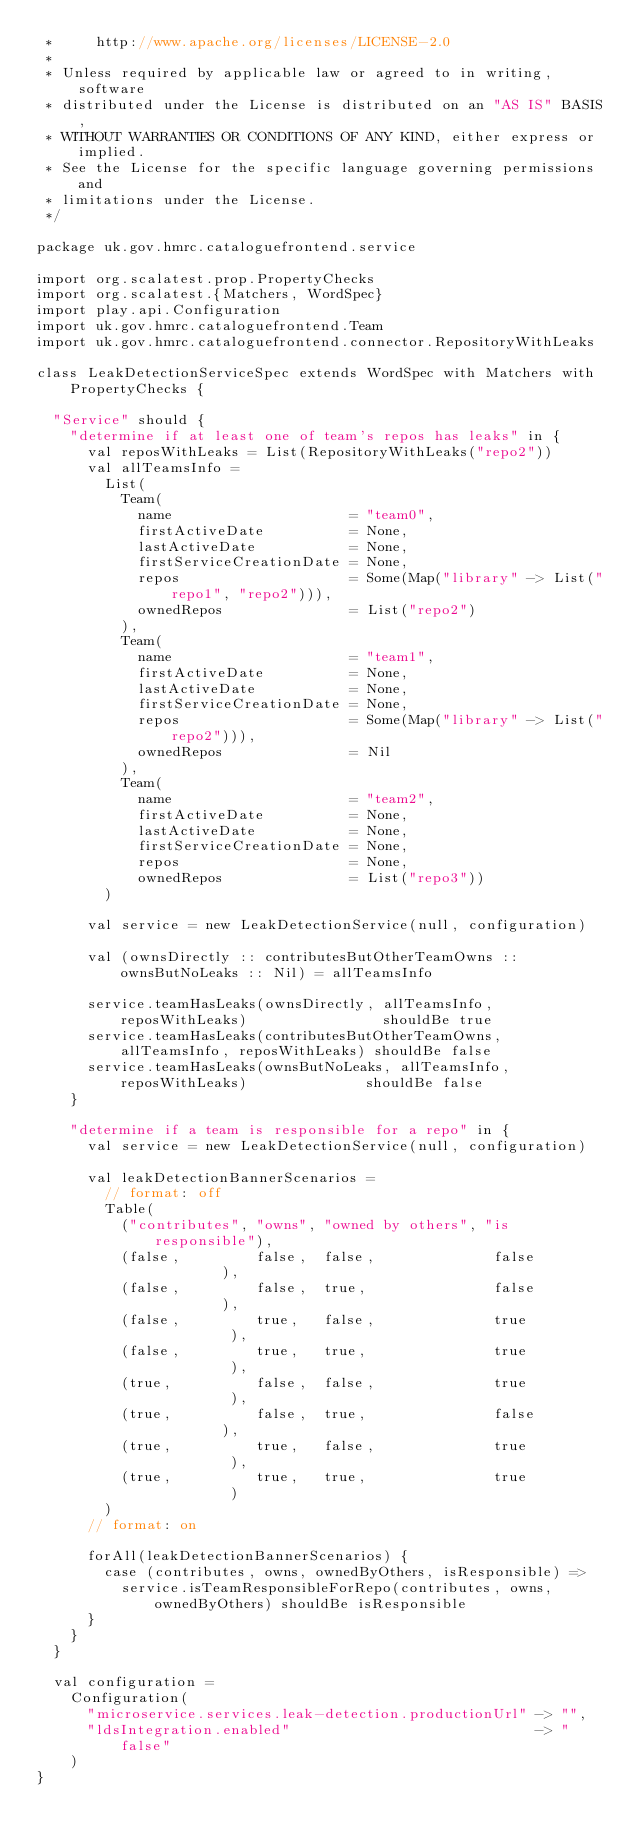Convert code to text. <code><loc_0><loc_0><loc_500><loc_500><_Scala_> *     http://www.apache.org/licenses/LICENSE-2.0
 *
 * Unless required by applicable law or agreed to in writing, software
 * distributed under the License is distributed on an "AS IS" BASIS,
 * WITHOUT WARRANTIES OR CONDITIONS OF ANY KIND, either express or implied.
 * See the License for the specific language governing permissions and
 * limitations under the License.
 */

package uk.gov.hmrc.cataloguefrontend.service

import org.scalatest.prop.PropertyChecks
import org.scalatest.{Matchers, WordSpec}
import play.api.Configuration
import uk.gov.hmrc.cataloguefrontend.Team
import uk.gov.hmrc.cataloguefrontend.connector.RepositoryWithLeaks

class LeakDetectionServiceSpec extends WordSpec with Matchers with PropertyChecks {

  "Service" should {
    "determine if at least one of team's repos has leaks" in {
      val reposWithLeaks = List(RepositoryWithLeaks("repo2"))
      val allTeamsInfo =
        List(
          Team(
            name                     = "team0",
            firstActiveDate          = None,
            lastActiveDate           = None,
            firstServiceCreationDate = None,
            repos                    = Some(Map("library" -> List("repo1", "repo2"))),
            ownedRepos               = List("repo2")
          ),
          Team(
            name                     = "team1",
            firstActiveDate          = None,
            lastActiveDate           = None,
            firstServiceCreationDate = None,
            repos                    = Some(Map("library" -> List("repo2"))),
            ownedRepos               = Nil
          ),
          Team(
            name                     = "team2",
            firstActiveDate          = None,
            lastActiveDate           = None,
            firstServiceCreationDate = None,
            repos                    = None,
            ownedRepos               = List("repo3"))
        )

      val service = new LeakDetectionService(null, configuration)

      val (ownsDirectly :: contributesButOtherTeamOwns :: ownsButNoLeaks :: Nil) = allTeamsInfo

      service.teamHasLeaks(ownsDirectly, allTeamsInfo, reposWithLeaks)                shouldBe true
      service.teamHasLeaks(contributesButOtherTeamOwns, allTeamsInfo, reposWithLeaks) shouldBe false
      service.teamHasLeaks(ownsButNoLeaks, allTeamsInfo, reposWithLeaks)              shouldBe false
    }

    "determine if a team is responsible for a repo" in {
      val service = new LeakDetectionService(null, configuration)

      val leakDetectionBannerScenarios =
        // format: off
        Table(
          ("contributes", "owns", "owned by others", "is responsible"),
          (false,         false,  false,              false         ),
          (false,         false,  true,               false         ),
          (false,         true,   false,              true          ),
          (false,         true,   true,               true          ),
          (true,          false,  false,              true          ),
          (true,          false,  true,               false         ),
          (true,          true,   false,              true          ),
          (true,          true,   true,               true          )
        )
      // format: on

      forAll(leakDetectionBannerScenarios) {
        case (contributes, owns, ownedByOthers, isResponsible) =>
          service.isTeamResponsibleForRepo(contributes, owns, ownedByOthers) shouldBe isResponsible
      }
    }
  }

  val configuration =
    Configuration(
      "microservice.services.leak-detection.productionUrl" -> "",
      "ldsIntegration.enabled"                             -> "false"
    )
}
</code> 